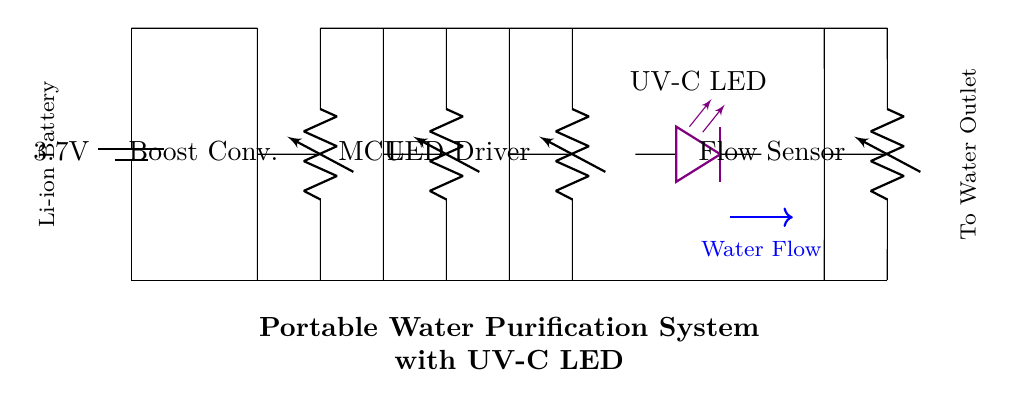What is the power source voltage? The circuit diagram shows a battery labeled with a voltage of 3.7 volts. This indicates the power source for the entire system.
Answer: 3.7 volts What does the UV-C LED do? The UV-C LED in the diagram is labeled specifically to emit ultraviolet light for water purification purposes. This is critical for killing pathogens in the water.
Answer: Purification Which component regulates voltage to the UV-C LED? The LED driver is responsible for regulating the voltage needed for the UV-C LED to function correctly, ensuring stable operation of the purification process.
Answer: LED Driver How many components are in the circuit? By counting the individual elements depicted in the diagram, we can identify six main components: the battery, boost converter, microcontroller, UV-C LED driver, UV-C LED, and flow sensor.
Answer: Six What is the function of the flow sensor? The flow sensor measures the water flow, allowing the system to monitor the flow rate, ensuring that sufficient water passes through the UV-C LED for effective purification.
Answer: Monitoring What happens when the water flow is insufficient? If the water flow indicated by the flow sensor is insufficient, the system might not activate the UV-C LED, which could prevent proper purification, rendering the water unsafe to drink.
Answer: Insufficient purification 